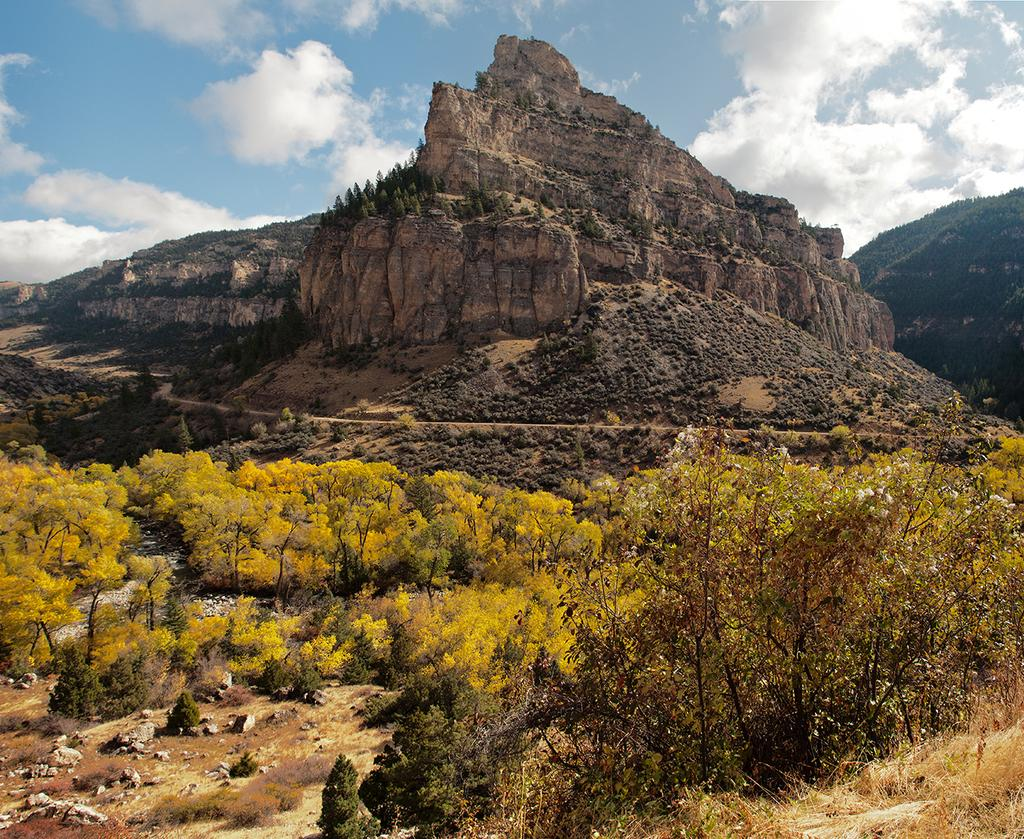What is located in the foreground of the image? There are plants in the foreground of the image. What can be seen in the background of the image? There are mountains and the sky visible in the background of the image. How many sisters are standing on the iron step in the image? There is no iron step or sisters present in the image. 